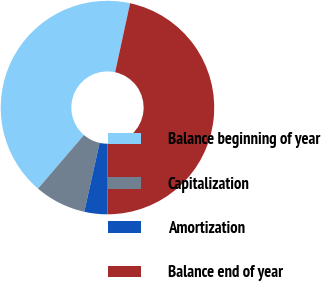Convert chart. <chart><loc_0><loc_0><loc_500><loc_500><pie_chart><fcel>Balance beginning of year<fcel>Capitalization<fcel>Amortization<fcel>Balance end of year<nl><fcel>42.12%<fcel>7.79%<fcel>3.47%<fcel>46.62%<nl></chart> 